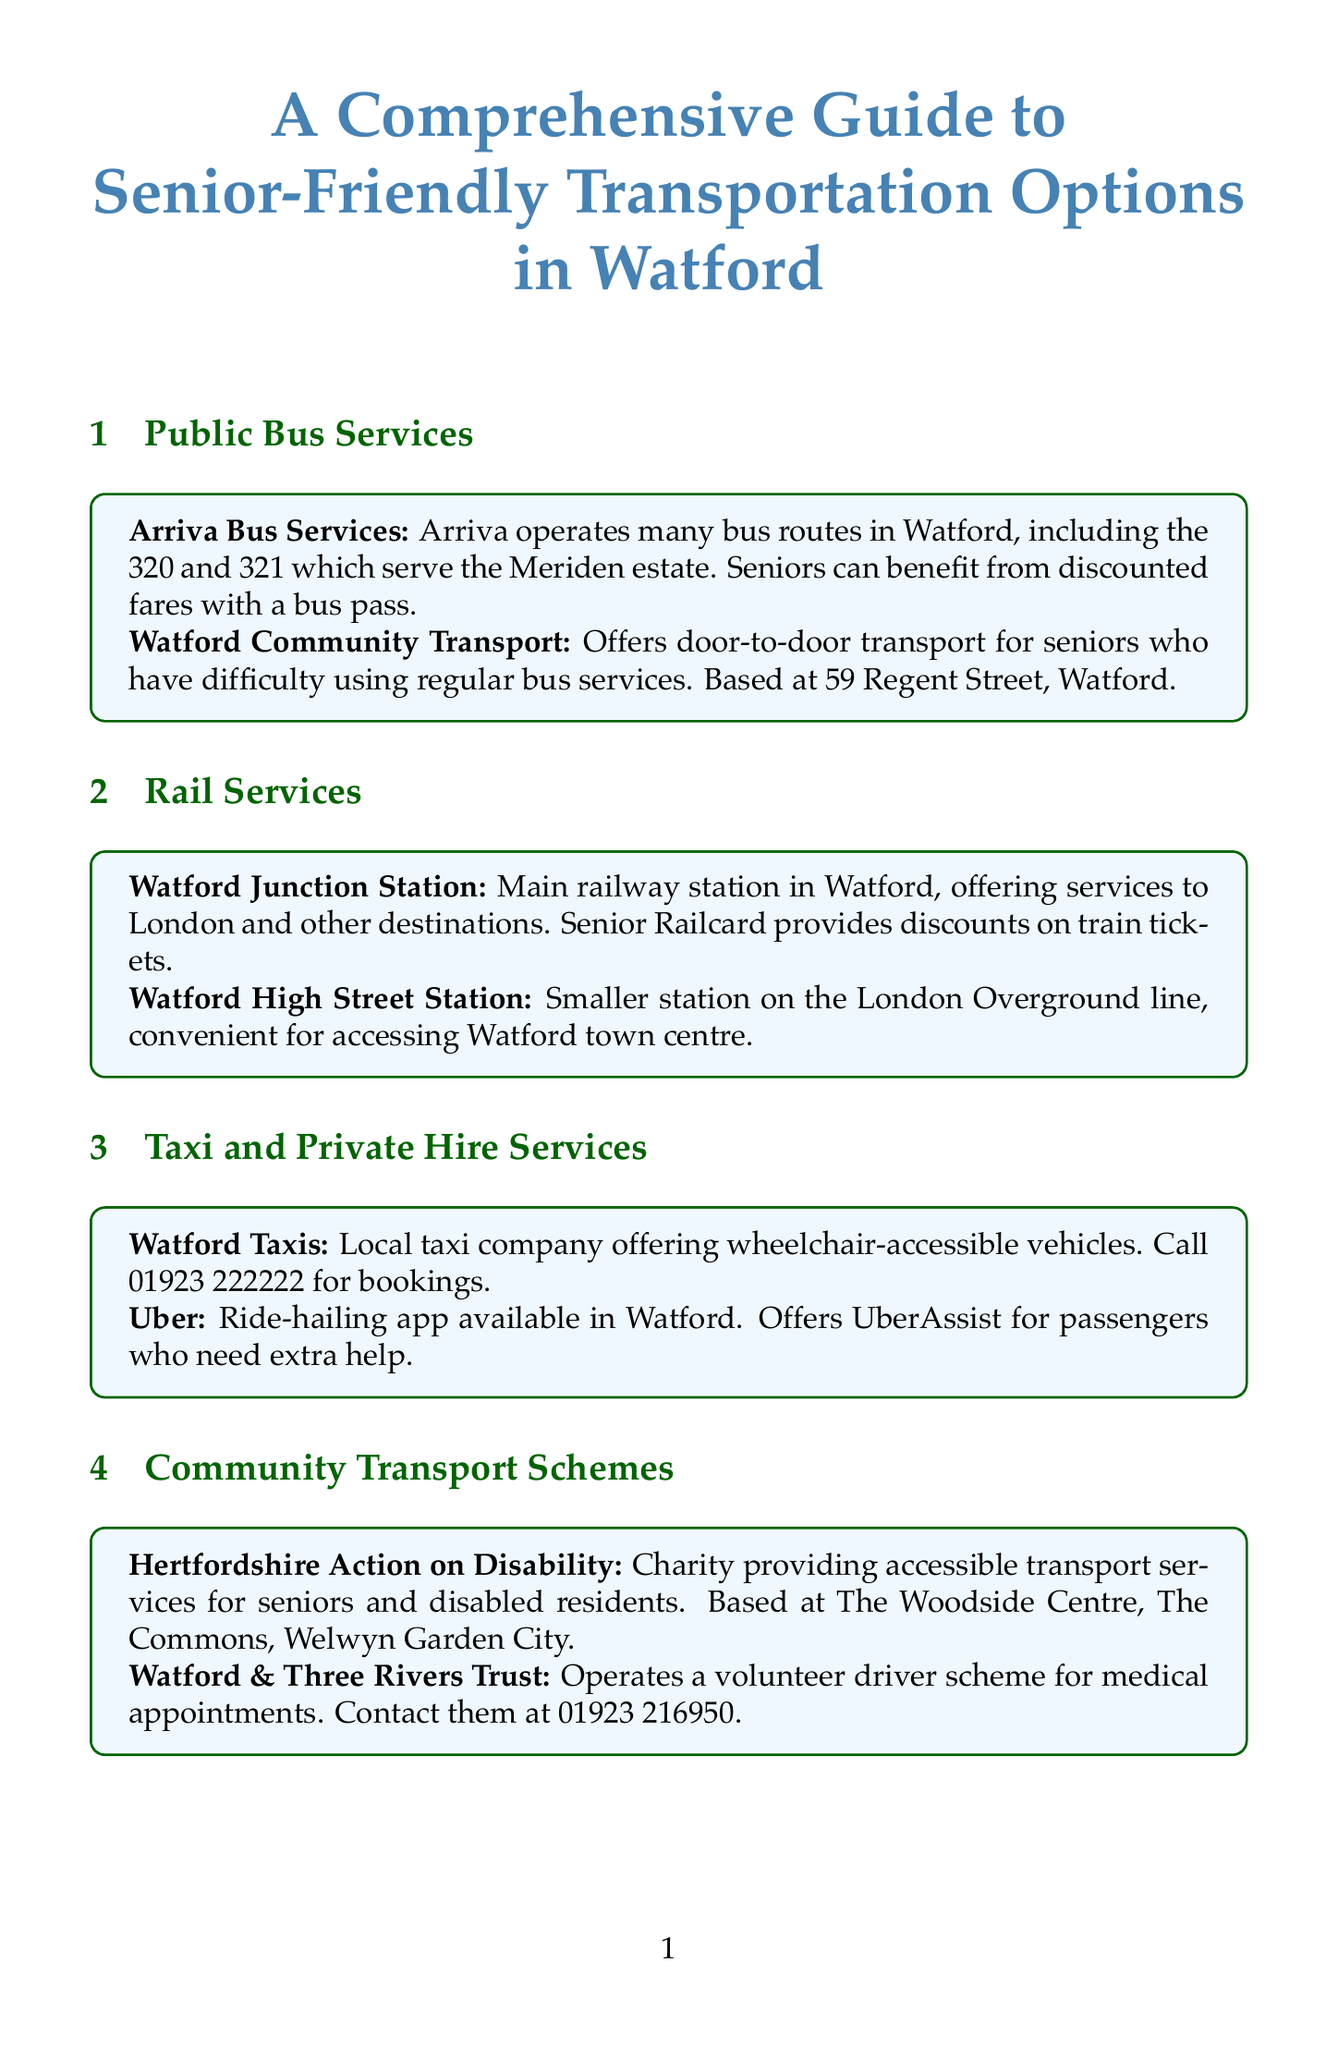What bus routes serve the Meriden estate? The document lists the 320 and 321 bus routes operated by Arriva as serving the Meriden estate.
Answer: 320 and 321 What is the contact number for Watford Taxis? The document provides the contact number for Watford Taxis as 01923 222222.
Answer: 01923 222222 Where can seniors get mobility scooters in Watford? Shopmobility Watford, located in the intu Watford shopping centre, offers mobility scooter hire.
Answer: intu Watford shopping centre Which charity provides accessible transport services for seniors? The document mentions Hertfordshire Action on Disability as a charity providing these services.
Answer: Hertfordshire Action on Disability How many railway stations are mentioned in the document? The document lists two railway stations that are relevant: Watford Junction and Watford High Street.
Answer: Two What type of transport does Watford Community Transport provide? The document states that Watford Community Transport offers door-to-door transport for seniors.
Answer: Door-to-door transport What is the purpose of the Watford & Three Rivers Trust? The document states that this trust operates a volunteer driver scheme for medical appointments.
Answer: Volunteer driver scheme for medical appointments How far is Cassiobury Park from the Meriden estate? The document indicates that Cassiobury Park is located just 2 miles from the Meriden estate.
Answer: 2 miles 